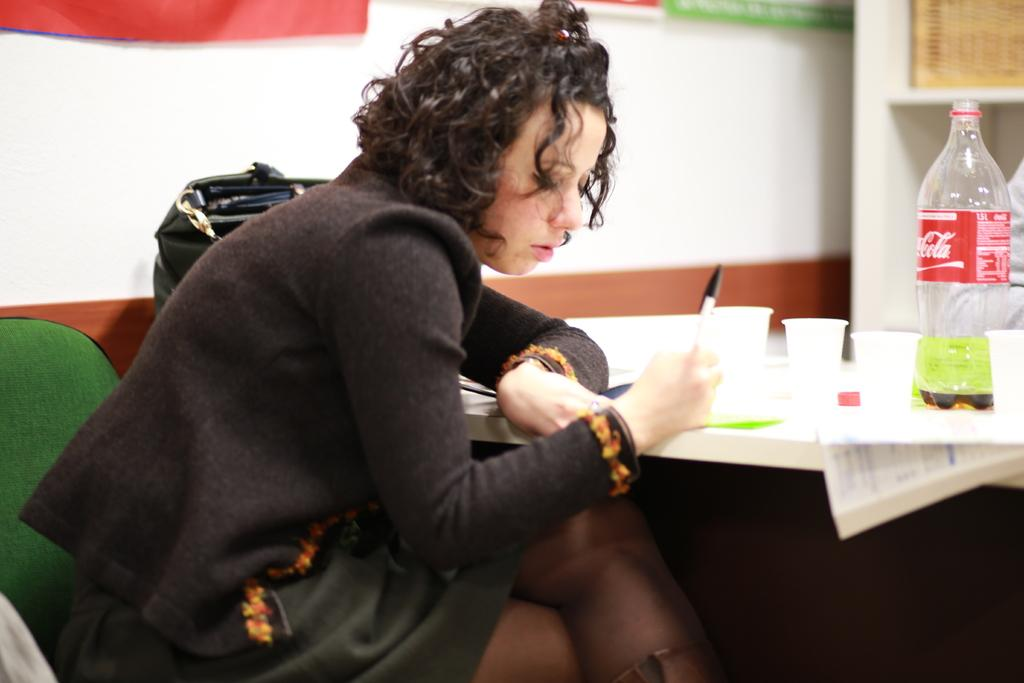What is the woman in the image doing? The woman is sitting on a chair in the image. Where is the woman located in relation to the table? The woman is near a table in the image. What items can be seen on the table? There is a cup, a bottle, and a purse on the table in the image. What type of bucket is being used to hold the reason for breaking the rule in the image? There is no bucket, reason, or rule present in the image. 